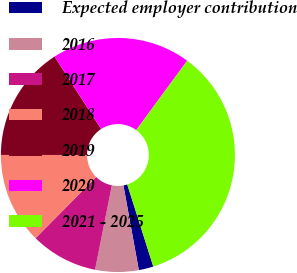Convert chart. <chart><loc_0><loc_0><loc_500><loc_500><pie_chart><fcel>Expected employer contribution<fcel>2016<fcel>2017<fcel>2018<fcel>2019<fcel>2020<fcel>2021 - 2025<nl><fcel>2.03%<fcel>5.99%<fcel>9.29%<fcel>12.59%<fcel>15.89%<fcel>19.19%<fcel>35.02%<nl></chart> 